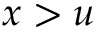Convert formula to latex. <formula><loc_0><loc_0><loc_500><loc_500>x > u</formula> 